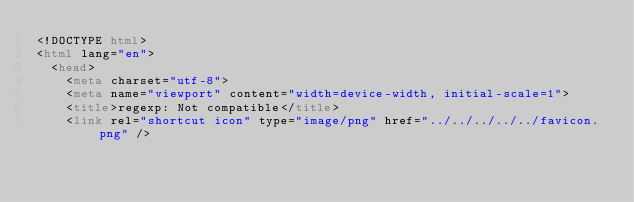Convert code to text. <code><loc_0><loc_0><loc_500><loc_500><_HTML_><!DOCTYPE html>
<html lang="en">
  <head>
    <meta charset="utf-8">
    <meta name="viewport" content="width=device-width, initial-scale=1">
    <title>regexp: Not compatible</title>
    <link rel="shortcut icon" type="image/png" href="../../../../../favicon.png" /></code> 